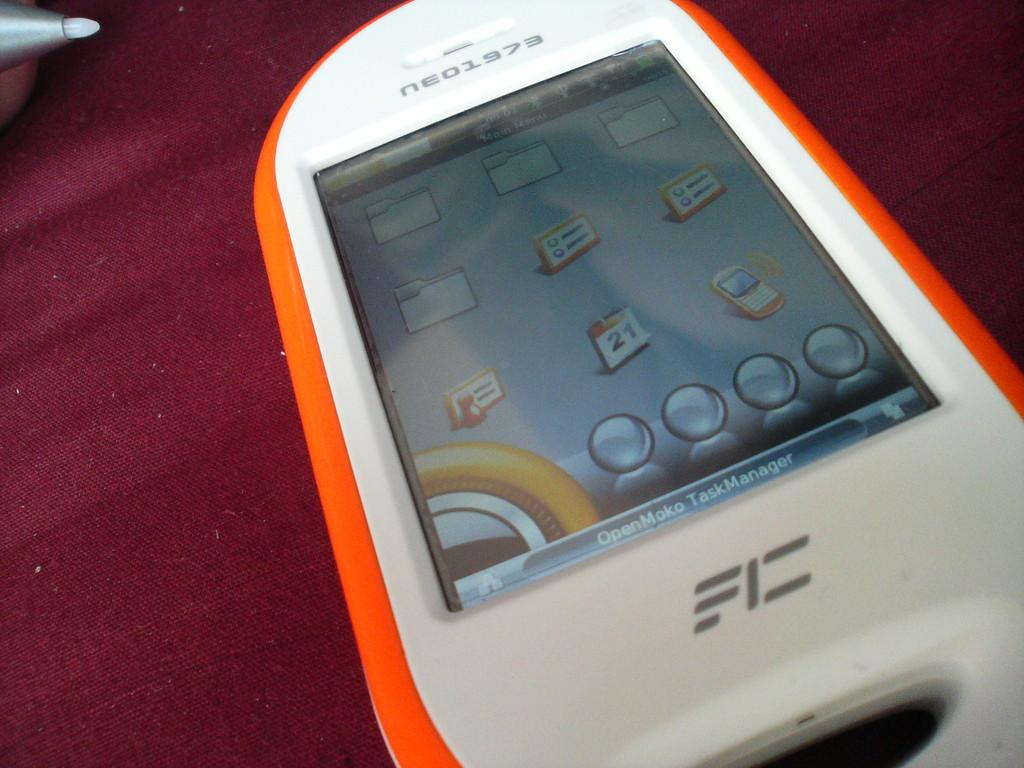<image>
Render a clear and concise summary of the photo. An electronic device that says neo1973 on it. 